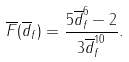Convert formula to latex. <formula><loc_0><loc_0><loc_500><loc_500>\overline { F } ( \overline { d } _ { f } ) = \frac { 5 \overline { d } _ { f } ^ { 6 } - 2 } { 3 \overline { d } _ { f } ^ { 1 0 } } .</formula> 